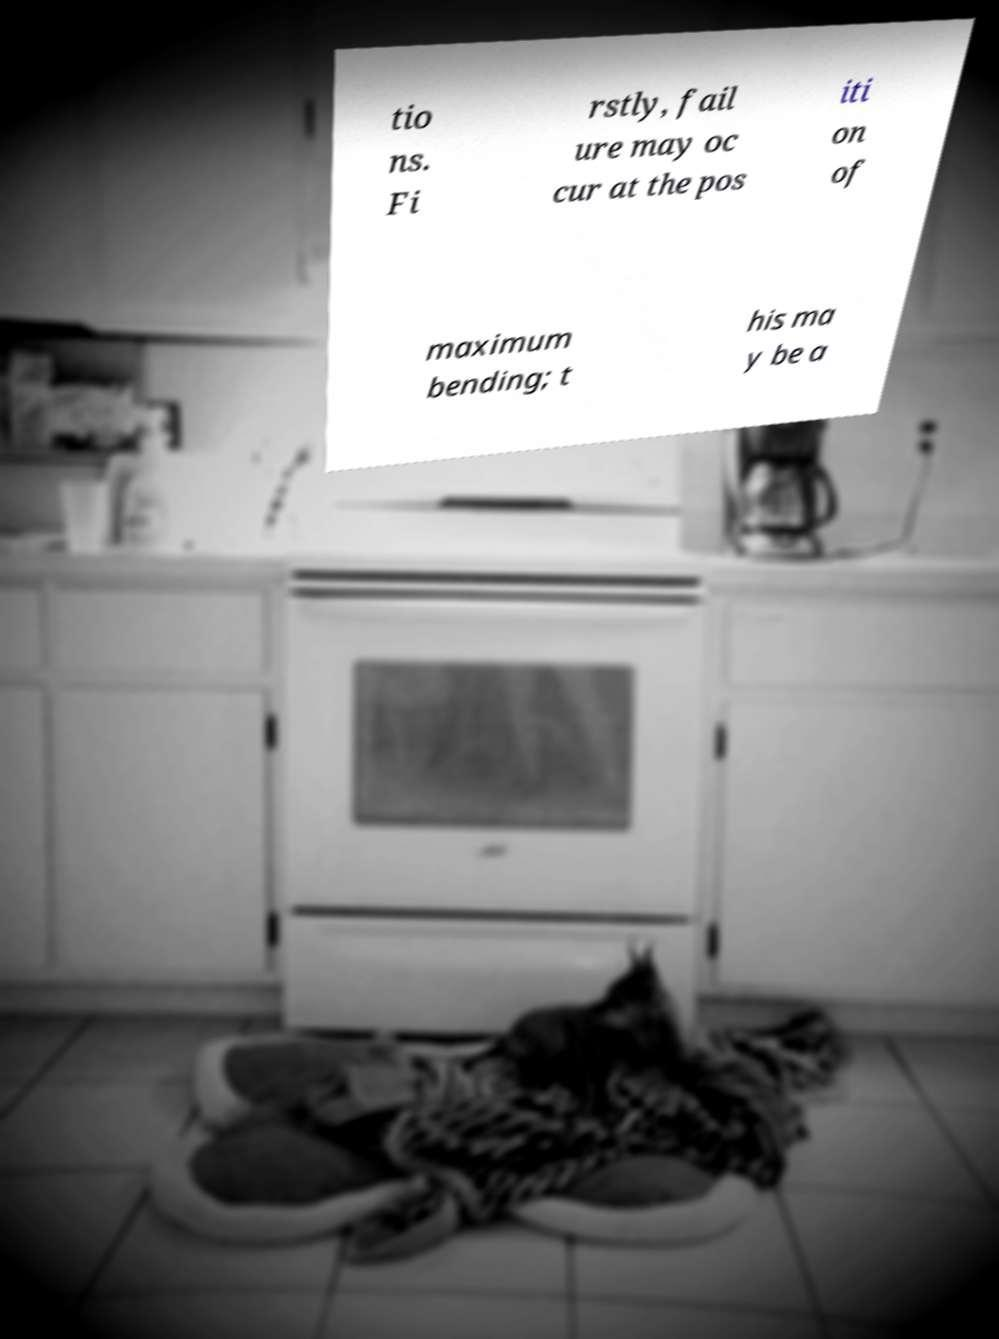What messages or text are displayed in this image? I need them in a readable, typed format. tio ns. Fi rstly, fail ure may oc cur at the pos iti on of maximum bending; t his ma y be a 